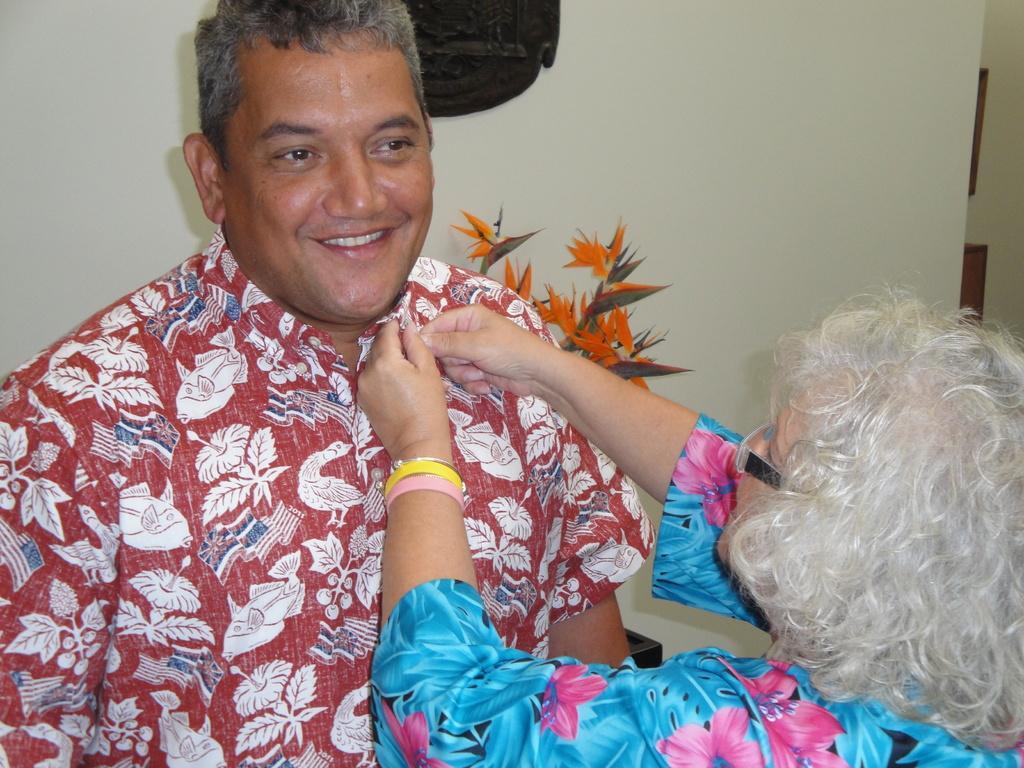How would you summarize this image in a sentence or two? In this image, we can see two people and one of them is wearing glasses. In the background, there is a houseplant and we can see some objects on the wall. 